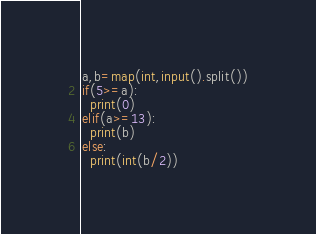Convert code to text. <code><loc_0><loc_0><loc_500><loc_500><_Python_>a,b=map(int,input().split())
if(5>=a):
  print(0)
elif(a>=13):
  print(b)
else:
  print(int(b/2))</code> 